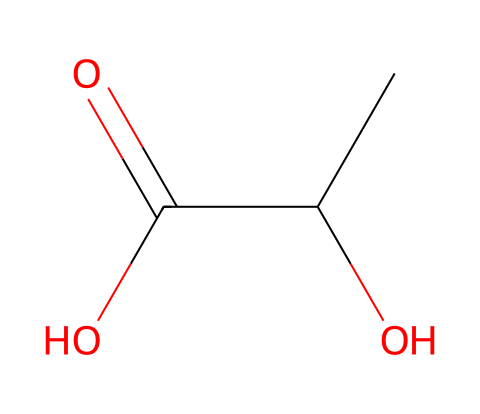What is the molecular formula of lactic acid? The SMILES representation indicates the atoms present: C, C, O, O, and O, which leads to the formula C3H6O3.
Answer: C3H6O3 How many carbon atoms are in lactic acid? The SMILES structure shows three 'C' symbols, indicating three carbon atoms.
Answer: 3 What functional groups are present in lactic acid? Analyzing the structure, there are a hydroxyl group (-OH) and a carboxyl group (-COOH), which are characteristic functional groups of lactic acid.
Answer: hydroxyl and carboxyl What type of acid is lactic acid? The presence of the carboxyl group (-COOH) in the structure identifies lactic acid as a carboxylic acid.
Answer: carboxylic acid Does lactic acid have polar or non-polar characteristics? Due to the presence of functional groups such as -OH and -COOH, lactic acid is polar.
Answer: polar What is the primary role of lactic acid in the body during exercise? Lactic acid is primarily produced during anaerobic respiration, serving as an energy source and being associated with muscle fatigue.
Answer: energy source What state is lactic acid typically found in? The chemical structure suggests it is a liquid at room temperature, as most small carboxylic acids are.
Answer: liquid 